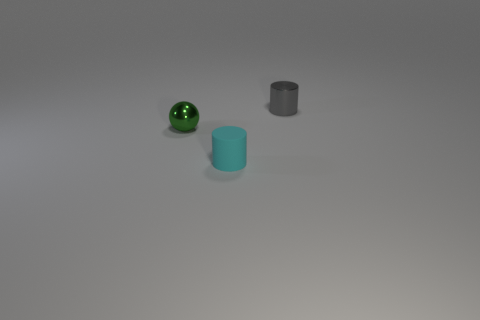Is there anything else that is the same shape as the green shiny object?
Your response must be concise. No. There is a green metal sphere; are there any tiny things right of it?
Your answer should be very brief. Yes. Is the ball made of the same material as the object right of the small cyan rubber cylinder?
Provide a succinct answer. Yes. There is a metal object on the right side of the cyan rubber cylinder; is it the same shape as the cyan thing?
Ensure brevity in your answer.  Yes. What number of small gray things have the same material as the green object?
Your response must be concise. 1. What number of things are either things to the left of the tiny cyan matte cylinder or gray shiny cylinders?
Offer a terse response. 2. The matte object has what size?
Offer a terse response. Small. There is a cylinder that is in front of the shiny object that is in front of the tiny gray cylinder; what is its material?
Offer a very short reply. Rubber. There is a matte cylinder in front of the gray metal thing; is its size the same as the tiny shiny cylinder?
Your answer should be compact. Yes. How many things are cyan things that are on the right side of the small green metal object or tiny metallic objects that are left of the small metal cylinder?
Offer a terse response. 2. 